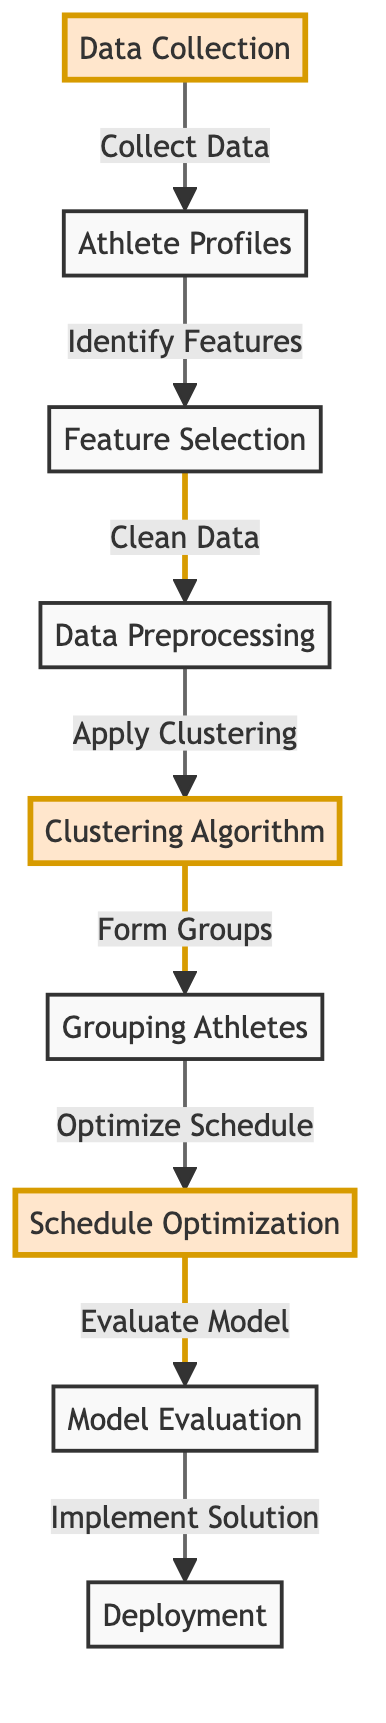What is the first step in the diagram? The first step is "Data Collection," which is the starting point of the entire training schedule optimization process. This node indicates that data needs to be collected before any further actions can be taken.
Answer: Data Collection How many main nodes are displayed in the diagram? The diagram contains eight main nodes which represent different stages in the process of optimizing training schedules for athletes.
Answer: Eight What is the last node in the diagram? The last node is "Deployment," which indicates that after model evaluation, the solution is implemented. This step signifies the culmination of the optimization process.
Answer: Deployment Which node follows "Data Preprocessing"? The node that follows "Data Preprocessing" is "Clustering Algorithm." This shows that after the data is cleaned and prepared, it will undergo clustering to form training groups.
Answer: Clustering Algorithm How many edges are directed out of the "Clustering Algorithm" node? There is one edge coming out of the "Clustering Algorithm" node that connects to the "Grouping Athletes" node, indicating the direct output of the clustering process.
Answer: One What action is performed after grouping athletes? The action performed after grouping athletes is "Schedule Optimization," which means the next step is to optimize the training schedules based on the formed athlete groups.
Answer: Schedule Optimization Which two nodes have a direct relationship? The nodes "Feature Selection" and "Data Preprocessing" have a direct relationship, as "Feature Selection" leads into "Data Preprocessing," indicating that after features are identified, the data must be cleaned.
Answer: Feature Selection and Data Preprocessing What is the purpose of the "Model Evaluation" node? The purpose of the "Model Evaluation" node is to assess the effectiveness of the optimized schedules and ensure the model's accuracy before deployment.
Answer: To assess effectiveness What color is the "Schedule Optimization" node? The "Schedule Optimization" node is colored in the emphasis style, indicating its significance in the diagram as a critical step in the process.
Answer: Emphasis color 